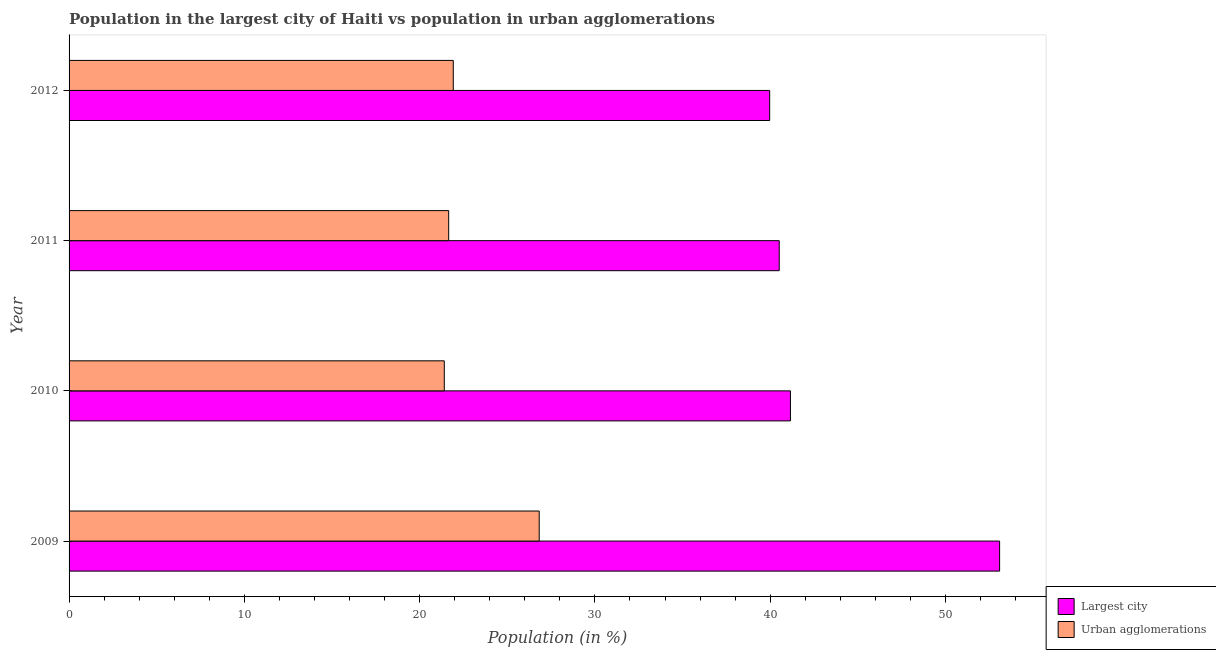How many different coloured bars are there?
Offer a terse response. 2. Are the number of bars per tick equal to the number of legend labels?
Your answer should be compact. Yes. Are the number of bars on each tick of the Y-axis equal?
Provide a short and direct response. Yes. How many bars are there on the 2nd tick from the top?
Offer a terse response. 2. In how many cases, is the number of bars for a given year not equal to the number of legend labels?
Your response must be concise. 0. What is the population in urban agglomerations in 2012?
Your answer should be very brief. 21.92. Across all years, what is the maximum population in urban agglomerations?
Offer a very short reply. 26.82. Across all years, what is the minimum population in the largest city?
Give a very brief answer. 39.97. What is the total population in the largest city in the graph?
Offer a very short reply. 174.73. What is the difference between the population in urban agglomerations in 2009 and that in 2010?
Your answer should be compact. 5.42. What is the difference between the population in the largest city in 2010 and the population in urban agglomerations in 2012?
Offer a terse response. 19.23. What is the average population in the largest city per year?
Offer a terse response. 43.68. In the year 2010, what is the difference between the population in urban agglomerations and population in the largest city?
Your response must be concise. -19.75. What is the ratio of the population in the largest city in 2009 to that in 2012?
Ensure brevity in your answer.  1.33. Is the population in the largest city in 2009 less than that in 2012?
Keep it short and to the point. No. What is the difference between the highest and the second highest population in the largest city?
Make the answer very short. 11.93. What is the difference between the highest and the lowest population in the largest city?
Provide a succinct answer. 13.12. In how many years, is the population in the largest city greater than the average population in the largest city taken over all years?
Your answer should be compact. 1. Is the sum of the population in urban agglomerations in 2010 and 2012 greater than the maximum population in the largest city across all years?
Ensure brevity in your answer.  No. What does the 2nd bar from the top in 2009 represents?
Make the answer very short. Largest city. What does the 1st bar from the bottom in 2011 represents?
Offer a terse response. Largest city. How many bars are there?
Ensure brevity in your answer.  8. Are all the bars in the graph horizontal?
Provide a succinct answer. Yes. What is the difference between two consecutive major ticks on the X-axis?
Give a very brief answer. 10. Are the values on the major ticks of X-axis written in scientific E-notation?
Give a very brief answer. No. Does the graph contain grids?
Offer a terse response. No. How many legend labels are there?
Your response must be concise. 2. How are the legend labels stacked?
Your answer should be compact. Vertical. What is the title of the graph?
Provide a short and direct response. Population in the largest city of Haiti vs population in urban agglomerations. What is the label or title of the Y-axis?
Provide a succinct answer. Year. What is the Population (in %) of Largest city in 2009?
Keep it short and to the point. 53.09. What is the Population (in %) of Urban agglomerations in 2009?
Ensure brevity in your answer.  26.82. What is the Population (in %) of Largest city in 2010?
Your answer should be compact. 41.16. What is the Population (in %) of Urban agglomerations in 2010?
Your answer should be very brief. 21.41. What is the Population (in %) of Largest city in 2011?
Make the answer very short. 40.52. What is the Population (in %) in Urban agglomerations in 2011?
Ensure brevity in your answer.  21.66. What is the Population (in %) of Largest city in 2012?
Offer a very short reply. 39.97. What is the Population (in %) of Urban agglomerations in 2012?
Provide a succinct answer. 21.92. Across all years, what is the maximum Population (in %) in Largest city?
Offer a very short reply. 53.09. Across all years, what is the maximum Population (in %) in Urban agglomerations?
Ensure brevity in your answer.  26.82. Across all years, what is the minimum Population (in %) in Largest city?
Give a very brief answer. 39.97. Across all years, what is the minimum Population (in %) in Urban agglomerations?
Give a very brief answer. 21.41. What is the total Population (in %) in Largest city in the graph?
Your response must be concise. 174.73. What is the total Population (in %) of Urban agglomerations in the graph?
Keep it short and to the point. 91.81. What is the difference between the Population (in %) in Largest city in 2009 and that in 2010?
Ensure brevity in your answer.  11.93. What is the difference between the Population (in %) in Urban agglomerations in 2009 and that in 2010?
Offer a terse response. 5.41. What is the difference between the Population (in %) in Largest city in 2009 and that in 2011?
Your response must be concise. 12.57. What is the difference between the Population (in %) in Urban agglomerations in 2009 and that in 2011?
Ensure brevity in your answer.  5.16. What is the difference between the Population (in %) of Largest city in 2009 and that in 2012?
Offer a very short reply. 13.12. What is the difference between the Population (in %) in Urban agglomerations in 2009 and that in 2012?
Keep it short and to the point. 4.9. What is the difference between the Population (in %) of Largest city in 2010 and that in 2011?
Your answer should be compact. 0.64. What is the difference between the Population (in %) in Urban agglomerations in 2010 and that in 2011?
Give a very brief answer. -0.25. What is the difference between the Population (in %) of Largest city in 2010 and that in 2012?
Your response must be concise. 1.18. What is the difference between the Population (in %) in Urban agglomerations in 2010 and that in 2012?
Give a very brief answer. -0.51. What is the difference between the Population (in %) in Largest city in 2011 and that in 2012?
Ensure brevity in your answer.  0.55. What is the difference between the Population (in %) of Urban agglomerations in 2011 and that in 2012?
Provide a succinct answer. -0.26. What is the difference between the Population (in %) of Largest city in 2009 and the Population (in %) of Urban agglomerations in 2010?
Make the answer very short. 31.68. What is the difference between the Population (in %) of Largest city in 2009 and the Population (in %) of Urban agglomerations in 2011?
Ensure brevity in your answer.  31.43. What is the difference between the Population (in %) of Largest city in 2009 and the Population (in %) of Urban agglomerations in 2012?
Your answer should be compact. 31.17. What is the difference between the Population (in %) of Largest city in 2010 and the Population (in %) of Urban agglomerations in 2011?
Your answer should be compact. 19.5. What is the difference between the Population (in %) in Largest city in 2010 and the Population (in %) in Urban agglomerations in 2012?
Give a very brief answer. 19.23. What is the difference between the Population (in %) in Largest city in 2011 and the Population (in %) in Urban agglomerations in 2012?
Your answer should be compact. 18.6. What is the average Population (in %) in Largest city per year?
Keep it short and to the point. 43.68. What is the average Population (in %) of Urban agglomerations per year?
Provide a short and direct response. 22.95. In the year 2009, what is the difference between the Population (in %) of Largest city and Population (in %) of Urban agglomerations?
Offer a terse response. 26.27. In the year 2010, what is the difference between the Population (in %) in Largest city and Population (in %) in Urban agglomerations?
Your response must be concise. 19.75. In the year 2011, what is the difference between the Population (in %) in Largest city and Population (in %) in Urban agglomerations?
Provide a succinct answer. 18.86. In the year 2012, what is the difference between the Population (in %) in Largest city and Population (in %) in Urban agglomerations?
Give a very brief answer. 18.05. What is the ratio of the Population (in %) in Largest city in 2009 to that in 2010?
Offer a very short reply. 1.29. What is the ratio of the Population (in %) in Urban agglomerations in 2009 to that in 2010?
Make the answer very short. 1.25. What is the ratio of the Population (in %) of Largest city in 2009 to that in 2011?
Give a very brief answer. 1.31. What is the ratio of the Population (in %) in Urban agglomerations in 2009 to that in 2011?
Your answer should be compact. 1.24. What is the ratio of the Population (in %) in Largest city in 2009 to that in 2012?
Keep it short and to the point. 1.33. What is the ratio of the Population (in %) of Urban agglomerations in 2009 to that in 2012?
Your answer should be compact. 1.22. What is the ratio of the Population (in %) in Largest city in 2010 to that in 2011?
Provide a succinct answer. 1.02. What is the ratio of the Population (in %) of Urban agglomerations in 2010 to that in 2011?
Make the answer very short. 0.99. What is the ratio of the Population (in %) of Largest city in 2010 to that in 2012?
Ensure brevity in your answer.  1.03. What is the ratio of the Population (in %) of Urban agglomerations in 2010 to that in 2012?
Offer a terse response. 0.98. What is the ratio of the Population (in %) in Largest city in 2011 to that in 2012?
Your response must be concise. 1.01. What is the difference between the highest and the second highest Population (in %) in Largest city?
Provide a short and direct response. 11.93. What is the difference between the highest and the second highest Population (in %) of Urban agglomerations?
Provide a short and direct response. 4.9. What is the difference between the highest and the lowest Population (in %) of Largest city?
Provide a short and direct response. 13.12. What is the difference between the highest and the lowest Population (in %) of Urban agglomerations?
Your response must be concise. 5.41. 